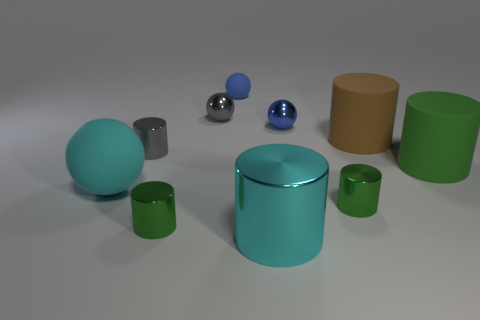Subtract all green cylinders. How many were subtracted if there are1green cylinders left? 2 Subtract all green balls. How many green cylinders are left? 3 Subtract all brown cylinders. How many cylinders are left? 5 Subtract all big cyan shiny cylinders. How many cylinders are left? 5 Subtract 2 cylinders. How many cylinders are left? 4 Subtract all yellow cylinders. Subtract all purple balls. How many cylinders are left? 6 Subtract all spheres. How many objects are left? 6 Add 1 small blue matte things. How many small blue matte things are left? 2 Add 5 large yellow spheres. How many large yellow spheres exist? 5 Subtract 0 yellow blocks. How many objects are left? 10 